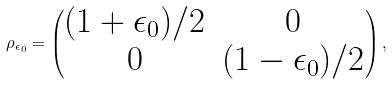<formula> <loc_0><loc_0><loc_500><loc_500>\rho _ { \epsilon _ { 0 } } = \begin{pmatrix} ( 1 + \epsilon _ { 0 } ) / 2 & 0 \\ 0 & ( 1 - \epsilon _ { 0 } ) / 2 \end{pmatrix} ,</formula> 